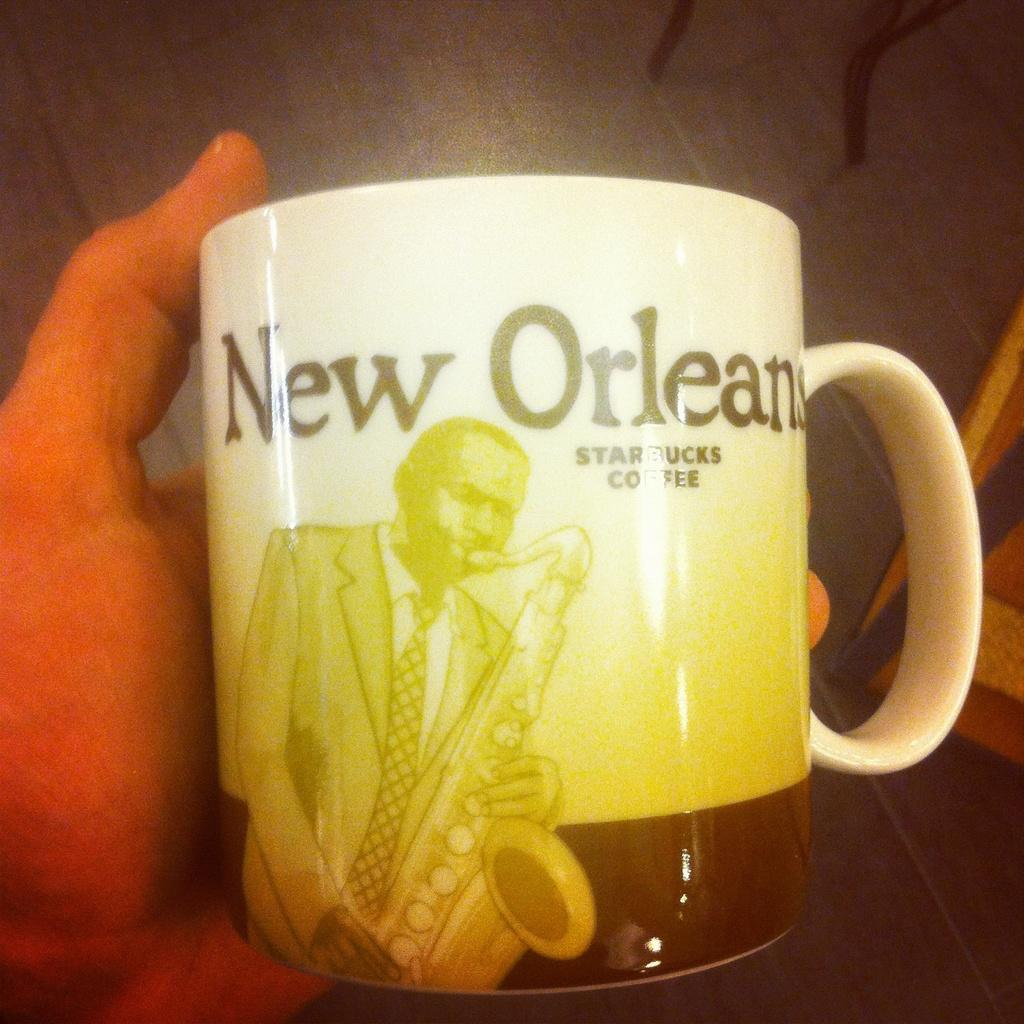Provide a one-sentence caption for the provided image. A starbucks coffee cup from New Orleans with a sax player on it. 